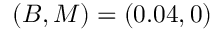<formula> <loc_0><loc_0><loc_500><loc_500>( B , M ) = ( 0 . 0 4 , 0 )</formula> 